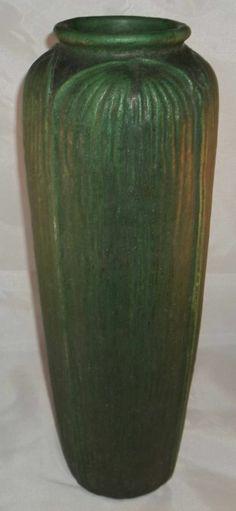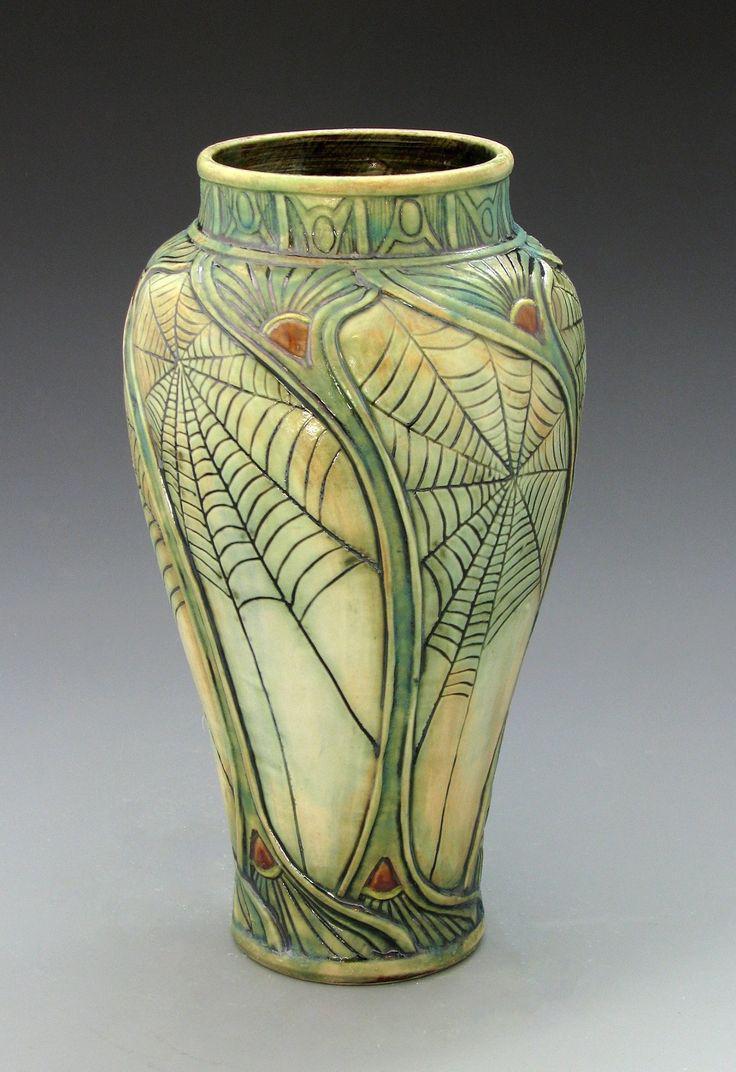The first image is the image on the left, the second image is the image on the right. Given the left and right images, does the statement "One of the vases is decorated with an illustrated design from top to bottom and shaped in a way that tapers to a smaller base." hold true? Answer yes or no. Yes. The first image is the image on the left, the second image is the image on the right. For the images displayed, is the sentence "In one image, a tall vase has an intricate faded green and yellow design with thin vertical elements running top to bottom, accented with small orange fan shapes." factually correct? Answer yes or no. Yes. 